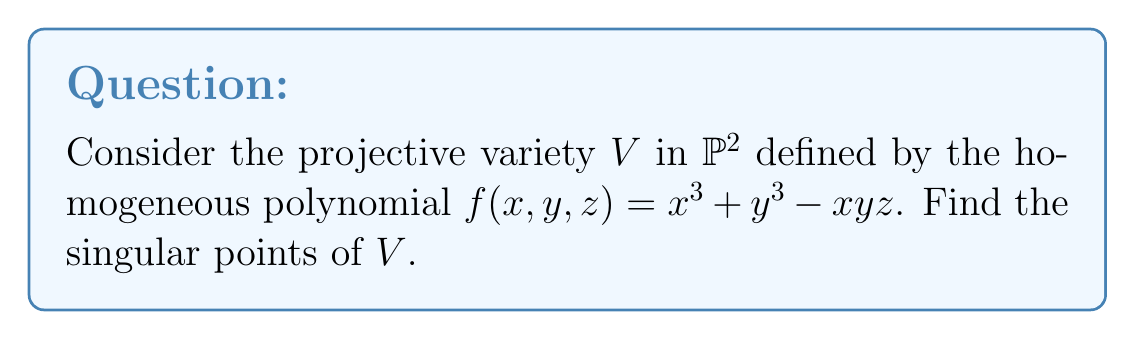What is the answer to this math problem? To find the singular points of the projective variety $V$, we need to follow these steps:

1) Calculate the partial derivatives of $f$ with respect to $x$, $y$, and $z$:

   $$\frac{\partial f}{\partial x} = 3x^2 - yz$$
   $$\frac{\partial f}{\partial y} = 3y^2 - xz$$
   $$\frac{\partial f}{\partial z} = -xy$$

2) The singular points are those where all partial derivatives vanish simultaneously with $f=0$. So, we need to solve the system:

   $$\begin{cases}
   x^3 + y^3 - xyz = 0 \\
   3x^2 - yz = 0 \\
   3y^2 - xz = 0 \\
   xy = 0
   \end{cases}$$

3) From the last equation, either $x=0$ or $y=0$. Let's consider each case:

   Case 1: If $x=0$, then from the second equation, $yz=0$. This means either $y=0$ or $z=0$.
   - If $y=0$, the point is $[0:0:1]$, but this doesn't satisfy $f=0$.
   - If $z=0$, then $y^3=0$, so $y=0$. Again, we get $[0:0:1]$, which doesn't work.

   Case 2: If $y=0$, then from the third equation, $xz=0$. This means either $x=0$ or $z=0$.
   - If $x=0$, we're back to $[0:0:1]$, which doesn't work.
   - If $z=0$, then $x^3=0$, so $x=0$. Again, we get $[0:0:1]$, which doesn't work.

4) The only remaining possibility is that neither $x$ nor $y$ is zero. In this case, from $xy=0$, we must have $z=0$. 

5) Substituting $z=0$ into the original equation:
   $$x^3 + y^3 = 0$$
   This can be factored as $(x+y)(x^2-xy+y^2)=0$

6) The solutions to this are $[1:-1:0]$ and $[1:\omega:0]$, where $\omega$ is a primitive cube root of unity.

7) We can verify that these points satisfy all the equations in step 2.

Therefore, the singular points of $V$ are $[1:-1:0]$, $[1:\omega:0]$, and $[1:\omega^2:0]$, where $\omega$ is a primitive cube root of unity.
Answer: $[1:-1:0]$, $[1:\omega:0]$, $[1:\omega^2:0]$, where $\omega$ is a primitive cube root of unity. 